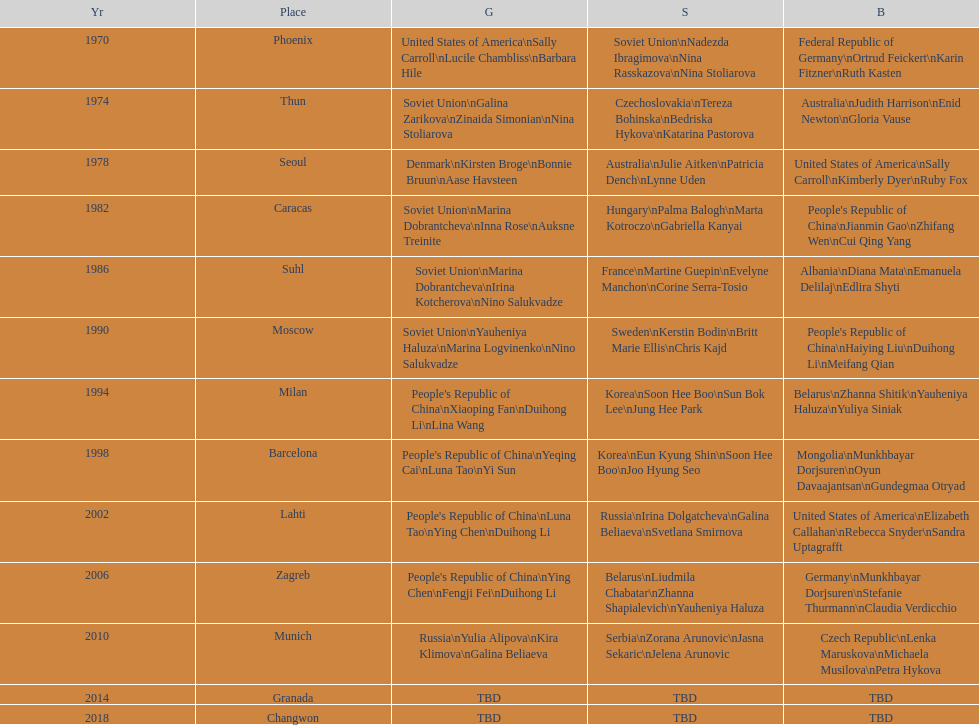Name one of the top three women to earn gold at the 1970 world championship held in phoenix, az Sally Carroll. 